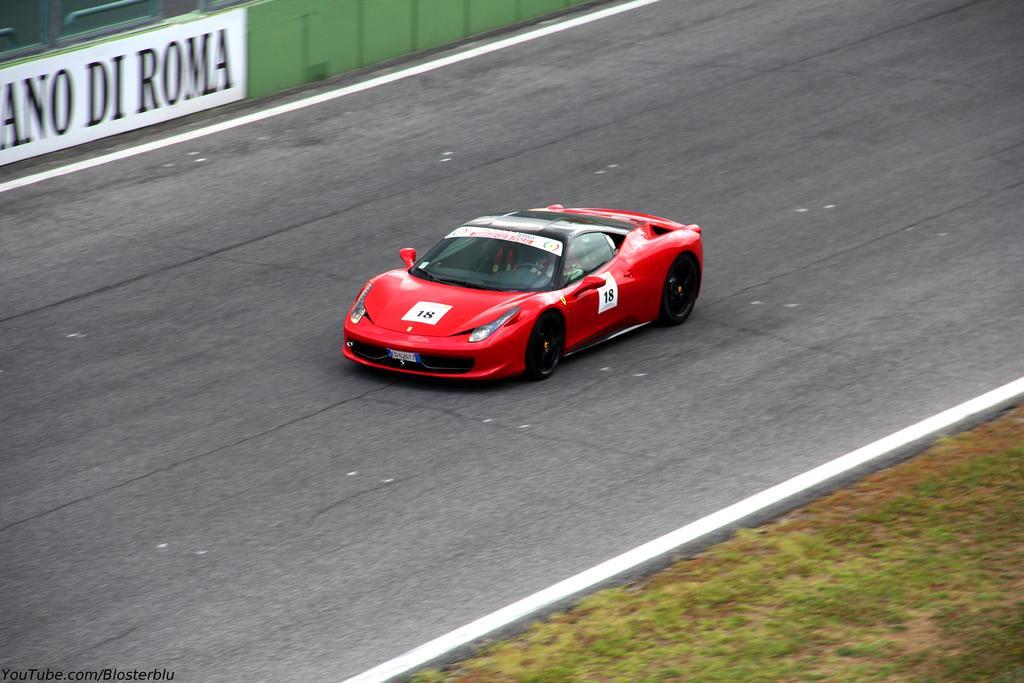In one or two sentences, can you explain what this image depicts? In this picture we can see a person is sitting in a sports car and the car is on the road. Behind the car there is a board and on the right side of the car there is the grass. 